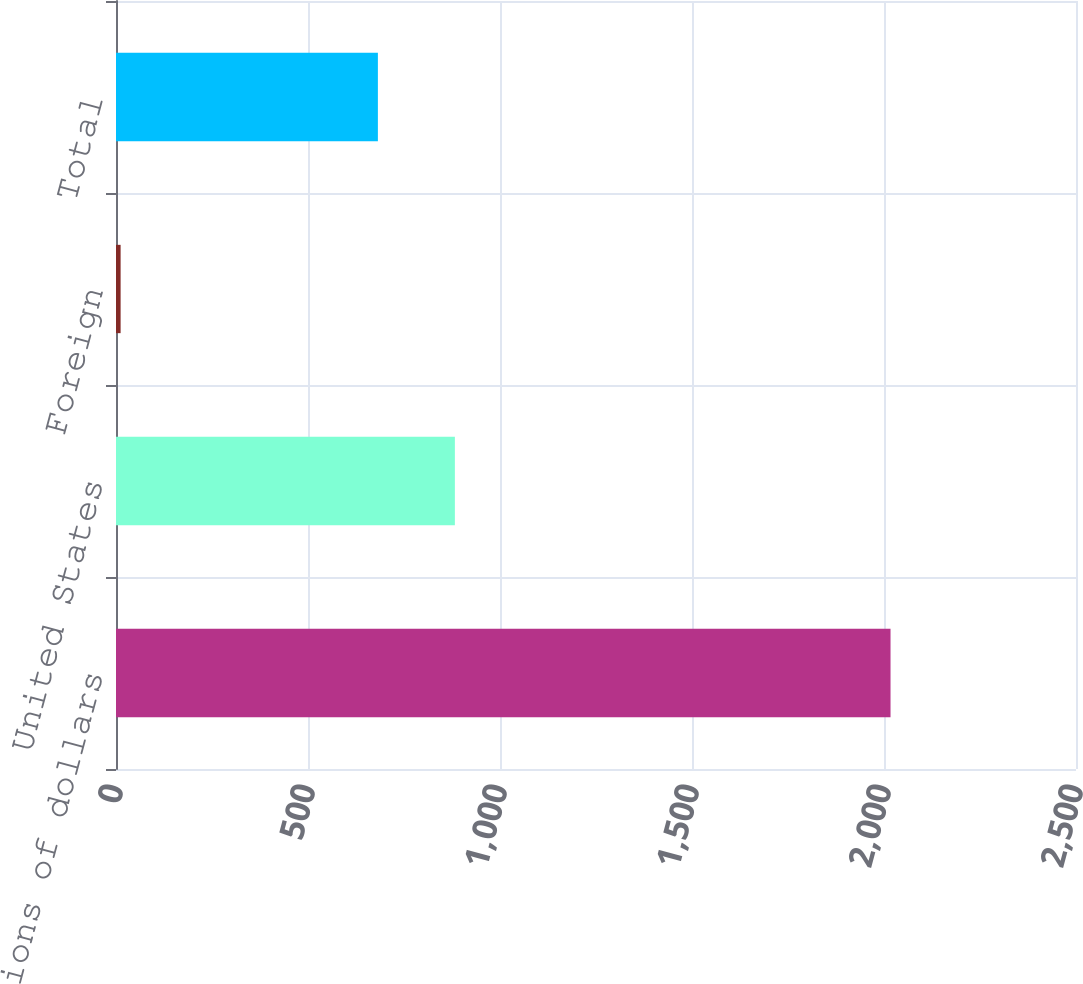Convert chart. <chart><loc_0><loc_0><loc_500><loc_500><bar_chart><fcel>Millions of dollars<fcel>United States<fcel>Foreign<fcel>Total<nl><fcel>2017<fcel>882.5<fcel>12<fcel>682<nl></chart> 